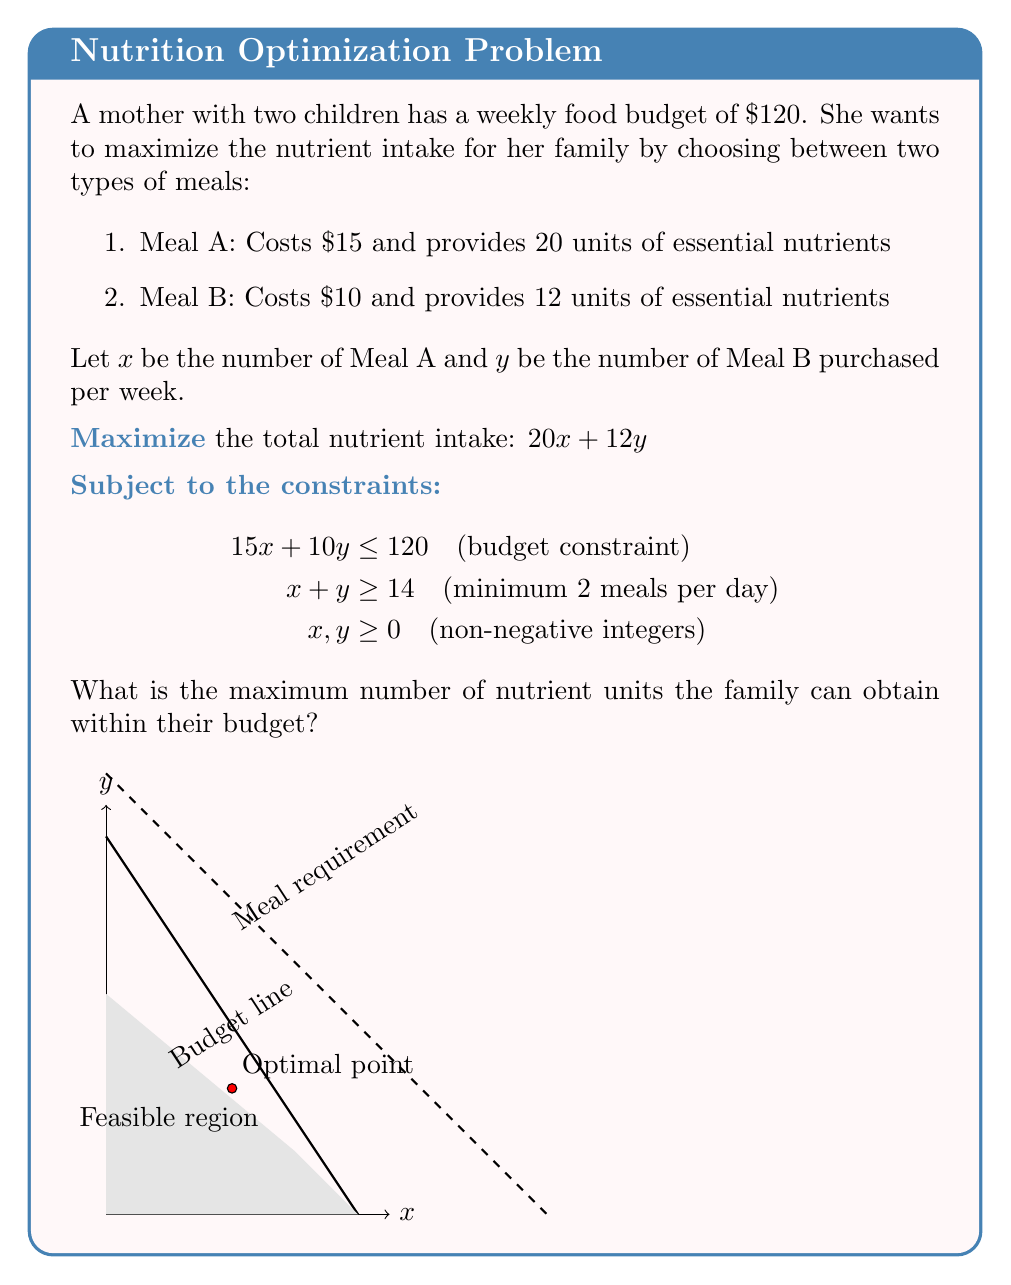What is the answer to this math problem? To solve this linear programming problem, we'll use the graphical method:

1) Plot the constraints:
   - Budget: $15x + 10y = 120$ (intercepts at (8,0) and (0,12))
   - Minimum meals: $x + y = 14$ (intercepts at (14,0) and (0,14))

2) Identify the feasible region (shaded area in the graph).

3) Find the corner points of the feasible region:
   (0,12), (0,14), (8,0), and the intersection of the two lines.

4) To find the intersection point, solve:
   $15x + 10y = 120$
   $x + y = 14$
   
   Subtracting the second equation from the first:
   $14x + 9y = 106$
   $x + y = 14$
   $13x + 8y = 92$
   $x = 4, y = 10$

5) Evaluate the objective function $f(x,y) = 20x + 12y$ at each corner point:
   (0,12): $f(0,12) = 0 + 12(12) = 144$
   (0,14): $f(0,14) = 0 + 12(14) = 168$
   (8,0): $f(8,0) = 20(8) + 0 = 160$
   (4,10): $f(4,10) = 20(4) + 12(10) = 200$

6) The maximum value occurs at (4,10), giving 200 nutrient units.
Answer: 200 nutrient units 